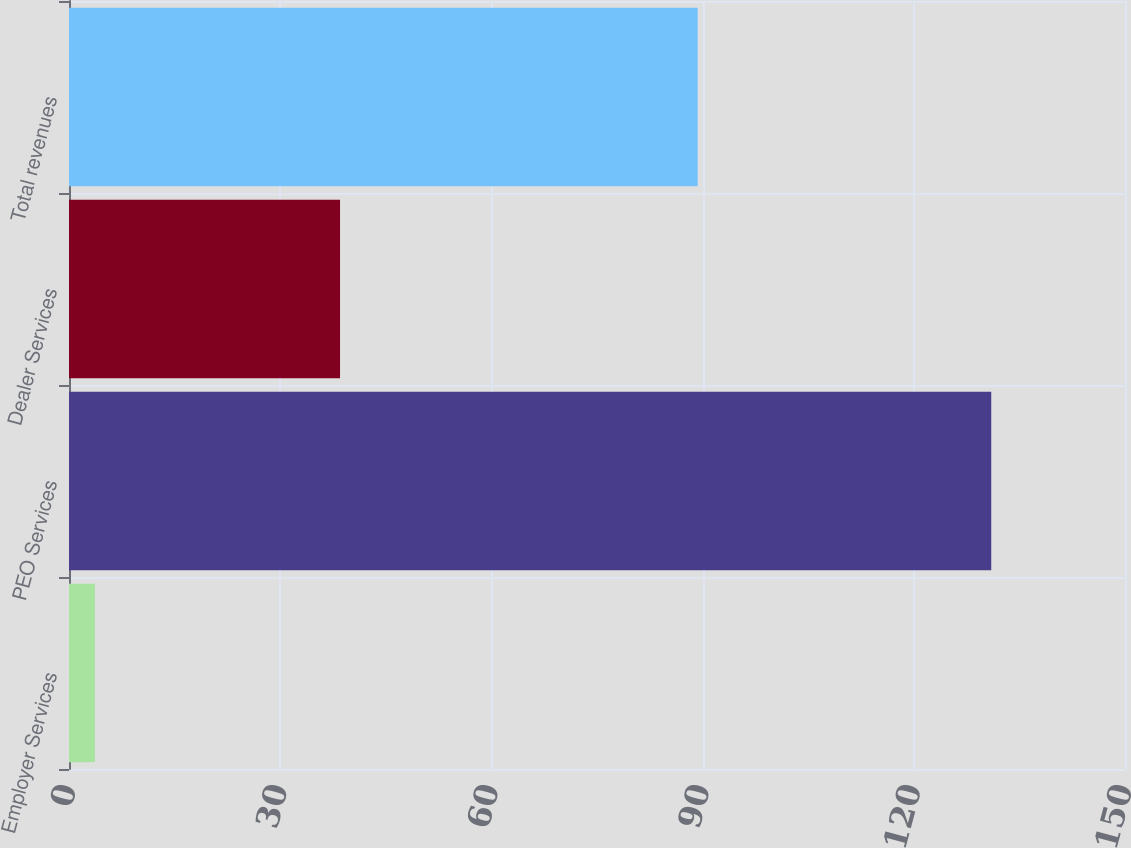Convert chart. <chart><loc_0><loc_0><loc_500><loc_500><bar_chart><fcel>Employer Services<fcel>PEO Services<fcel>Dealer Services<fcel>Total revenues<nl><fcel>3.7<fcel>131<fcel>38.5<fcel>89.3<nl></chart> 